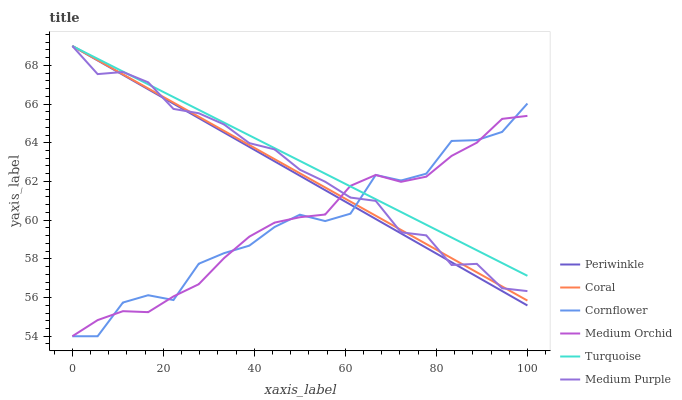Does Coral have the minimum area under the curve?
Answer yes or no. No. Does Coral have the maximum area under the curve?
Answer yes or no. No. Is Turquoise the smoothest?
Answer yes or no. No. Is Turquoise the roughest?
Answer yes or no. No. Does Coral have the lowest value?
Answer yes or no. No. Does Medium Orchid have the highest value?
Answer yes or no. No. 